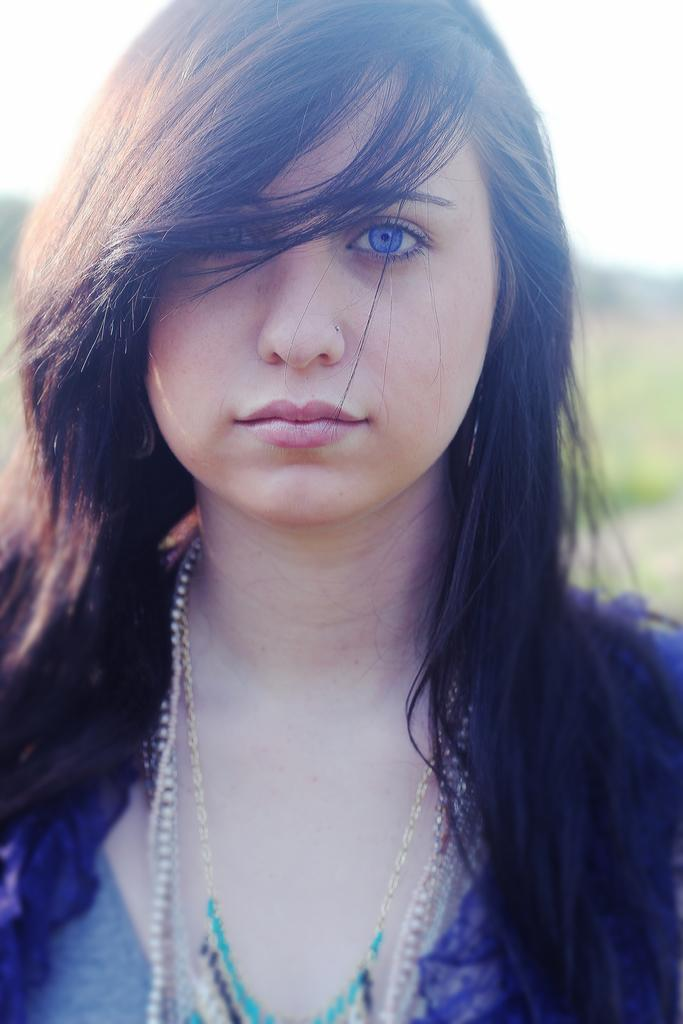Who is the main subject in the image? There is a woman in the image. What is the woman wearing? The woman is wearing a blue dress. What color are the woman's eyes? The woman has blue eyes. What is the woman's posture in the image? The woman is standing. What can be seen in the background of the image? There are trees in the background of the image. What is visible at the top of the image? The sky is visible at the top of the image. How many kittens are sitting on the woman's foot in the image? There are no kittens present in the image, and the woman's foot is not visible. 